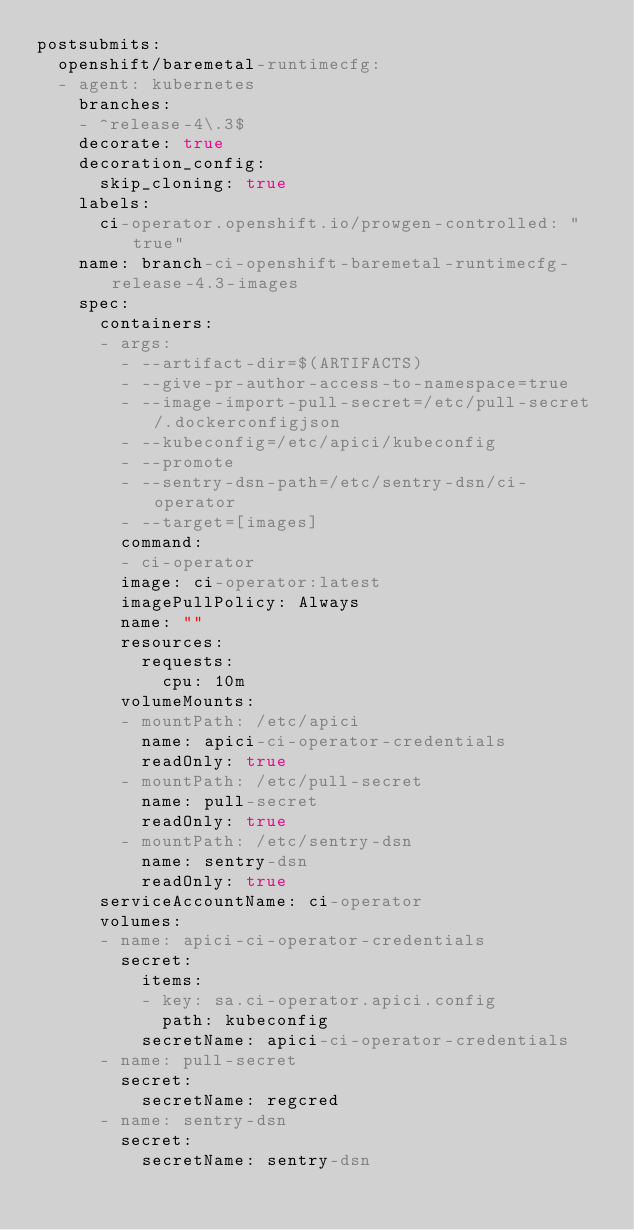<code> <loc_0><loc_0><loc_500><loc_500><_YAML_>postsubmits:
  openshift/baremetal-runtimecfg:
  - agent: kubernetes
    branches:
    - ^release-4\.3$
    decorate: true
    decoration_config:
      skip_cloning: true
    labels:
      ci-operator.openshift.io/prowgen-controlled: "true"
    name: branch-ci-openshift-baremetal-runtimecfg-release-4.3-images
    spec:
      containers:
      - args:
        - --artifact-dir=$(ARTIFACTS)
        - --give-pr-author-access-to-namespace=true
        - --image-import-pull-secret=/etc/pull-secret/.dockerconfigjson
        - --kubeconfig=/etc/apici/kubeconfig
        - --promote
        - --sentry-dsn-path=/etc/sentry-dsn/ci-operator
        - --target=[images]
        command:
        - ci-operator
        image: ci-operator:latest
        imagePullPolicy: Always
        name: ""
        resources:
          requests:
            cpu: 10m
        volumeMounts:
        - mountPath: /etc/apici
          name: apici-ci-operator-credentials
          readOnly: true
        - mountPath: /etc/pull-secret
          name: pull-secret
          readOnly: true
        - mountPath: /etc/sentry-dsn
          name: sentry-dsn
          readOnly: true
      serviceAccountName: ci-operator
      volumes:
      - name: apici-ci-operator-credentials
        secret:
          items:
          - key: sa.ci-operator.apici.config
            path: kubeconfig
          secretName: apici-ci-operator-credentials
      - name: pull-secret
        secret:
          secretName: regcred
      - name: sentry-dsn
        secret:
          secretName: sentry-dsn
</code> 